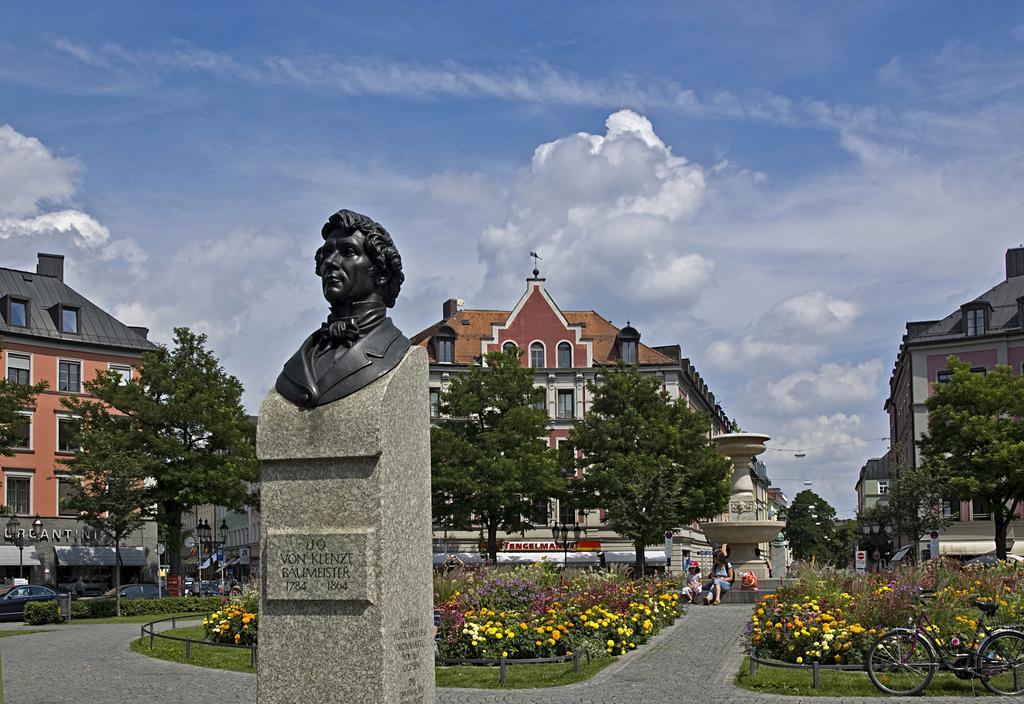In one or two sentences, can you explain what this image depicts? In this picture I can see the statue of a man which is placed on the stone. In the bottom right corner there is a bicycle which is parked near to the grass. Beside that I can see many flowers on the plants. In the back there are two women who are sitting on the stairs. In the background I can see the cars, street lights, sign boards, buildings and trees. At the top I can see the sky and clouds. 